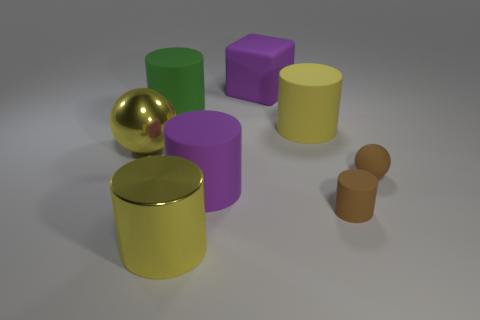Subtract all brown cylinders. How many cylinders are left? 4 Subtract all brown matte cylinders. How many cylinders are left? 4 Subtract 1 cylinders. How many cylinders are left? 4 Subtract all red cylinders. Subtract all cyan balls. How many cylinders are left? 5 Add 1 blocks. How many objects exist? 9 Subtract all cylinders. How many objects are left? 3 Add 3 large rubber cubes. How many large rubber cubes exist? 4 Subtract 1 brown cylinders. How many objects are left? 7 Subtract all large yellow metal spheres. Subtract all purple cylinders. How many objects are left? 6 Add 1 brown spheres. How many brown spheres are left? 2 